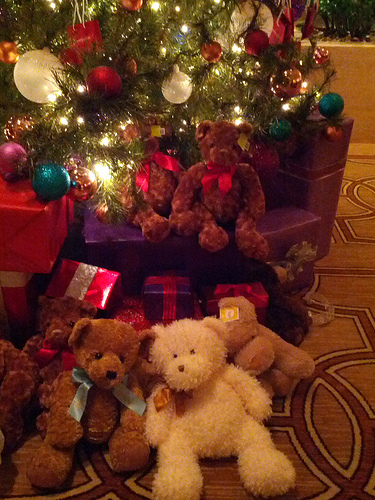<image>
Is there a teddy bear under the ornament? Yes. The teddy bear is positioned underneath the ornament, with the ornament above it in the vertical space. 